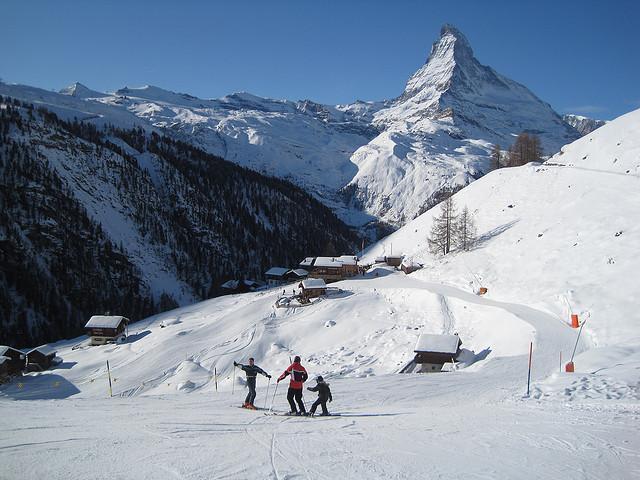What types of trees are these?
Indicate the correct response and explain using: 'Answer: answer
Rationale: rationale.'
Options: Eucalyptus, birches, evergreens, oaks. Answer: evergreens.
Rationale: They are the only trees that stay green in the winter. 